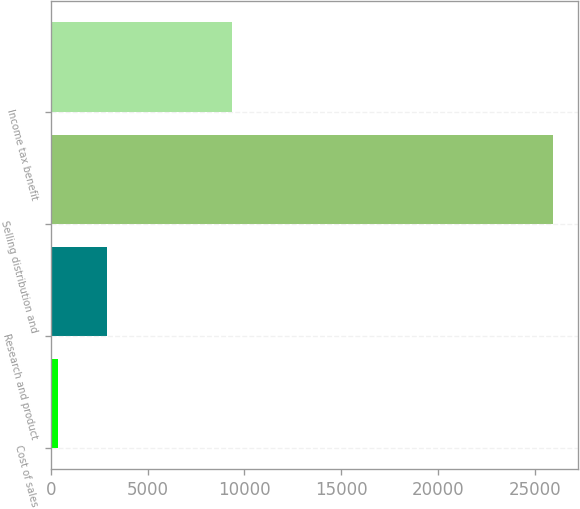<chart> <loc_0><loc_0><loc_500><loc_500><bar_chart><fcel>Cost of sales<fcel>Research and product<fcel>Selling distribution and<fcel>Income tax benefit<nl><fcel>374<fcel>2928.4<fcel>25918<fcel>9359<nl></chart> 